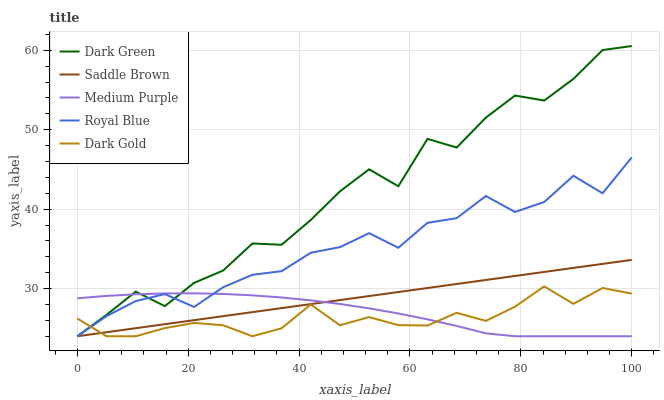Does Dark Gold have the minimum area under the curve?
Answer yes or no. Yes. Does Dark Green have the maximum area under the curve?
Answer yes or no. Yes. Does Royal Blue have the minimum area under the curve?
Answer yes or no. No. Does Royal Blue have the maximum area under the curve?
Answer yes or no. No. Is Saddle Brown the smoothest?
Answer yes or no. Yes. Is Dark Green the roughest?
Answer yes or no. Yes. Is Royal Blue the smoothest?
Answer yes or no. No. Is Royal Blue the roughest?
Answer yes or no. No. Does Medium Purple have the lowest value?
Answer yes or no. Yes. Does Dark Green have the highest value?
Answer yes or no. Yes. Does Royal Blue have the highest value?
Answer yes or no. No. Does Dark Gold intersect Royal Blue?
Answer yes or no. Yes. Is Dark Gold less than Royal Blue?
Answer yes or no. No. Is Dark Gold greater than Royal Blue?
Answer yes or no. No. 